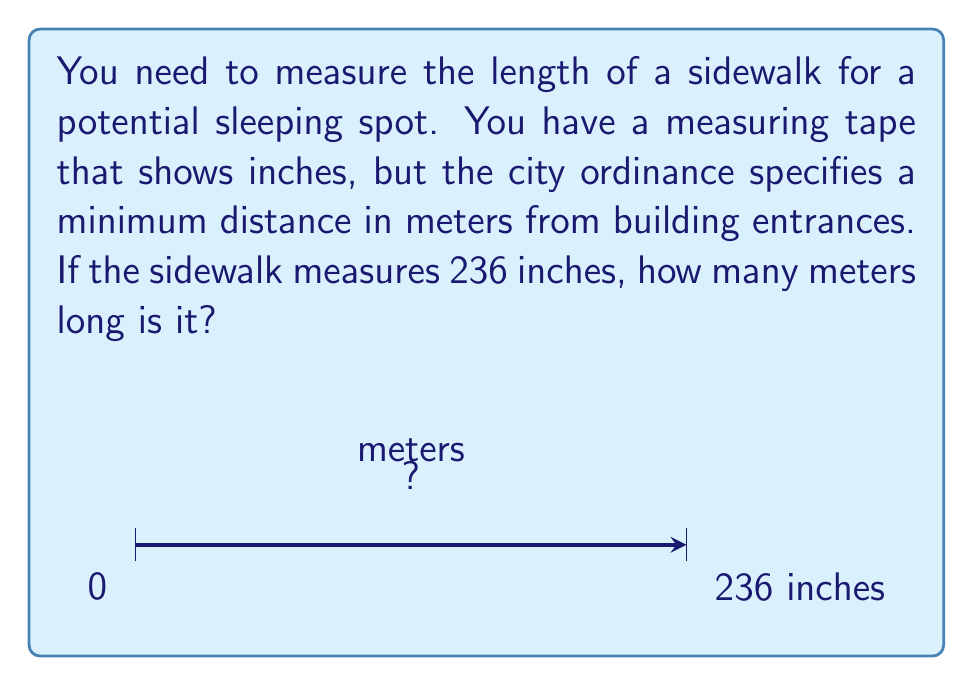What is the answer to this math problem? To convert from inches to meters, we need to follow these steps:

1) First, let's recall the conversion factor:
   1 inch = 2.54 cm = 0.0254 m

2) We can set up the conversion as follows:
   $$ 236 \text{ inches} \times \frac{0.0254 \text{ meters}}{1 \text{ inch}} $$

3) Now, let's perform the calculation:
   $$ 236 \times 0.0254 = 5.9944 \text{ meters} $$

4) Rounding to two decimal places (which is usually sufficient for practical measurements):
   $$ 5.9944 \text{ meters} \approx 5.99 \text{ meters} $$

Therefore, the 236-inch sidewalk is approximately 5.99 meters long.
Answer: 5.99 m 